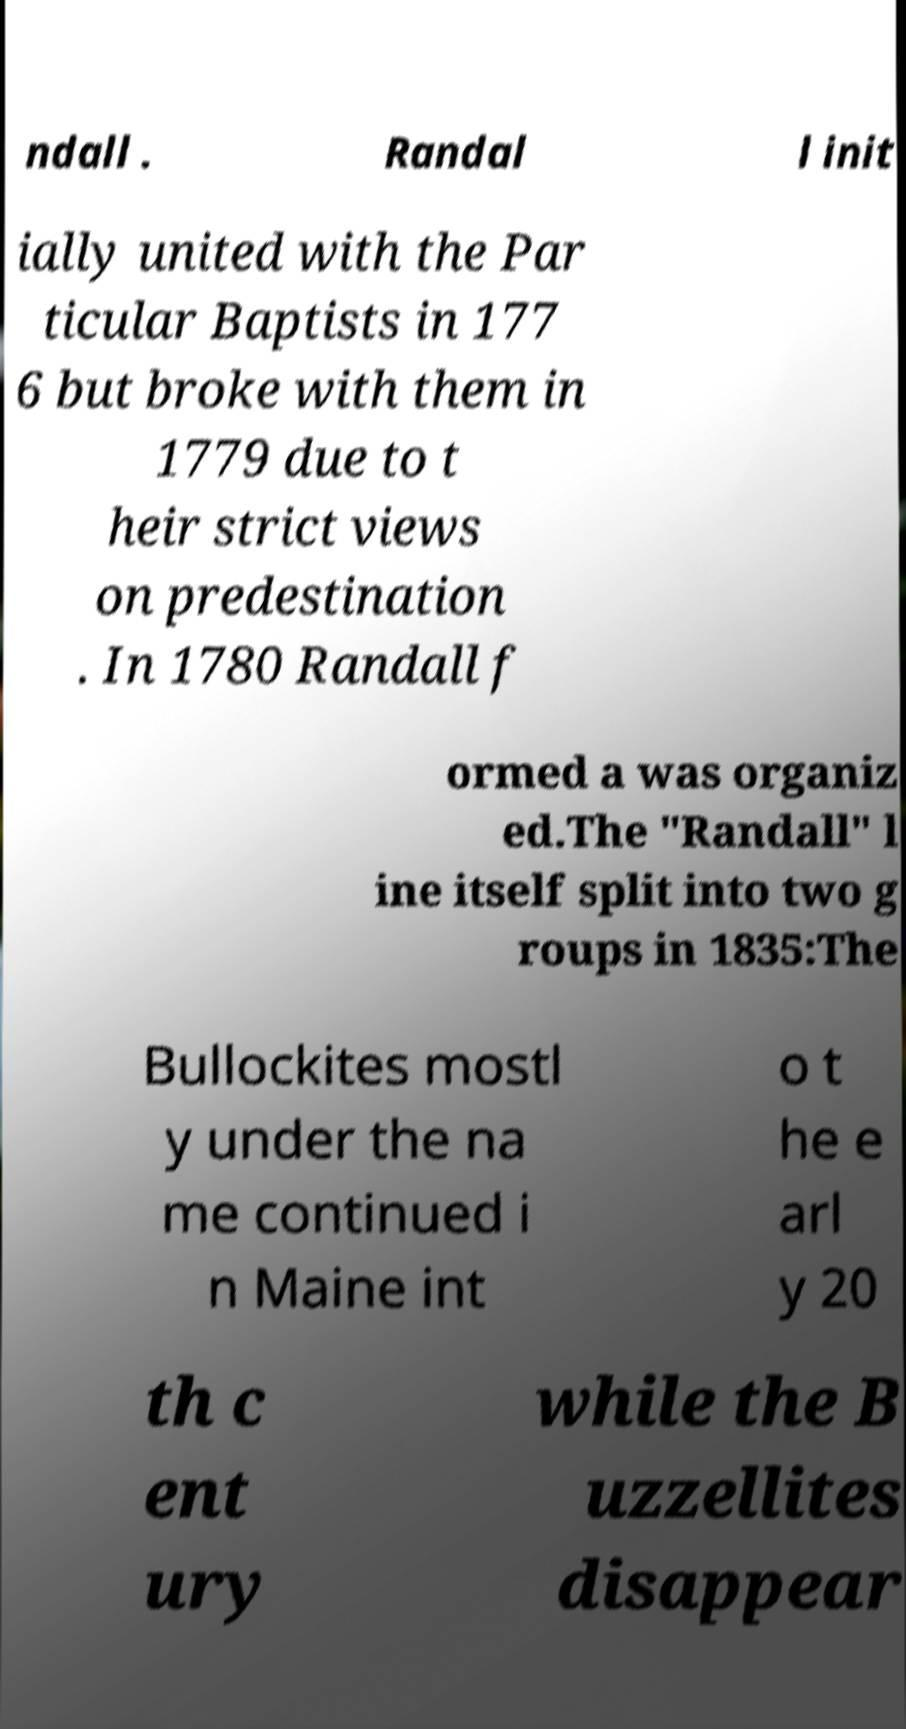Please identify and transcribe the text found in this image. ndall . Randal l init ially united with the Par ticular Baptists in 177 6 but broke with them in 1779 due to t heir strict views on predestination . In 1780 Randall f ormed a was organiz ed.The "Randall" l ine itself split into two g roups in 1835:The Bullockites mostl y under the na me continued i n Maine int o t he e arl y 20 th c ent ury while the B uzzellites disappear 